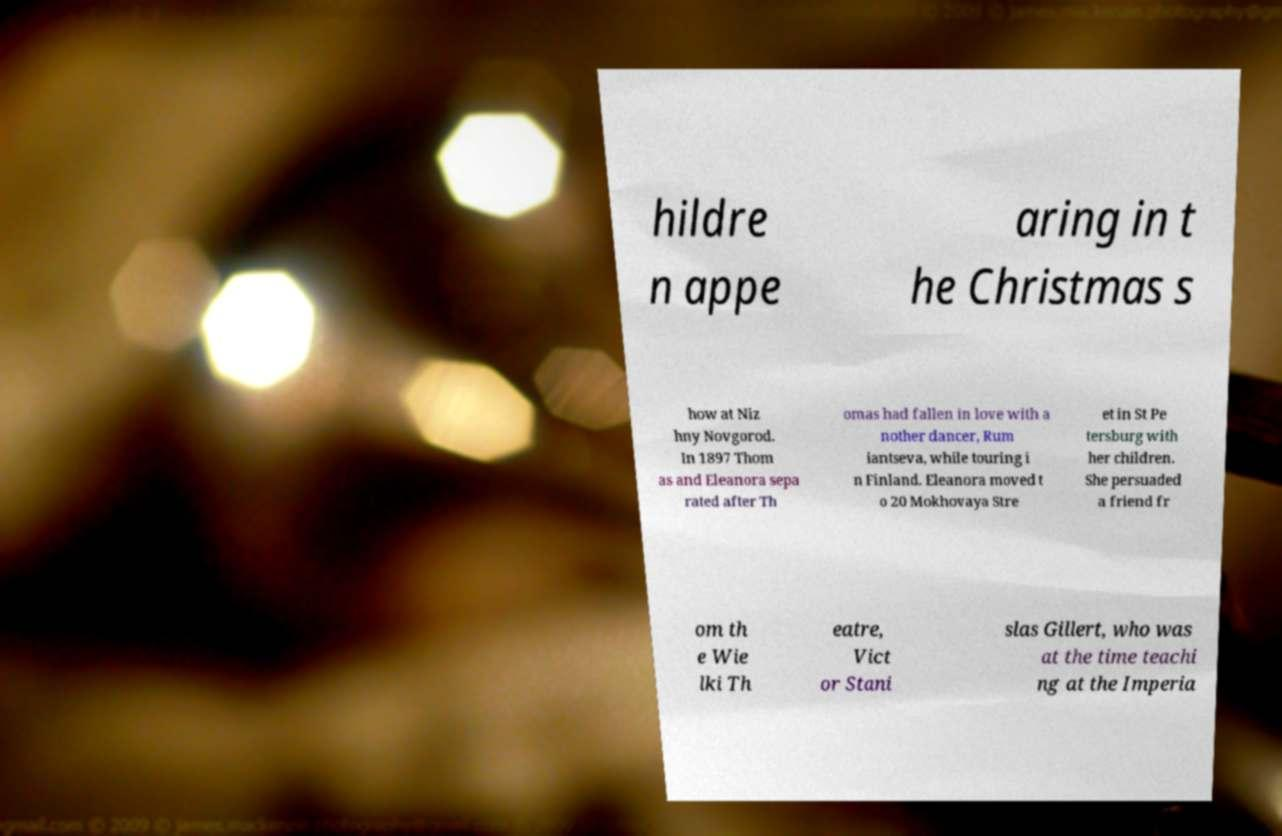I need the written content from this picture converted into text. Can you do that? hildre n appe aring in t he Christmas s how at Niz hny Novgorod. In 1897 Thom as and Eleanora sepa rated after Th omas had fallen in love with a nother dancer, Rum iantseva, while touring i n Finland. Eleanora moved t o 20 Mokhovaya Stre et in St Pe tersburg with her children. She persuaded a friend fr om th e Wie lki Th eatre, Vict or Stani slas Gillert, who was at the time teachi ng at the Imperia 